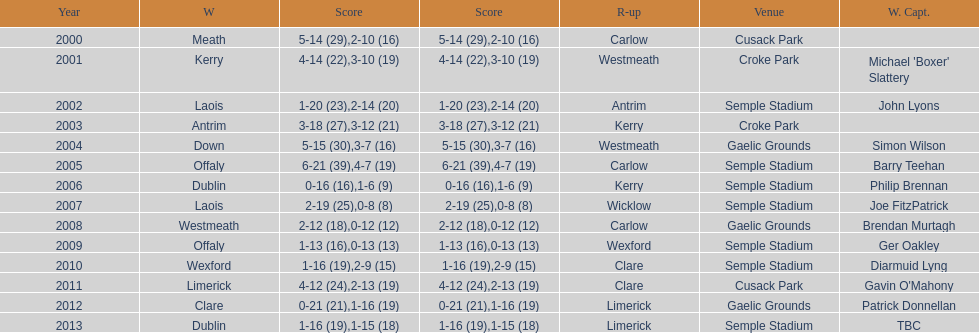Who was the first winner in 2013? Dublin. 